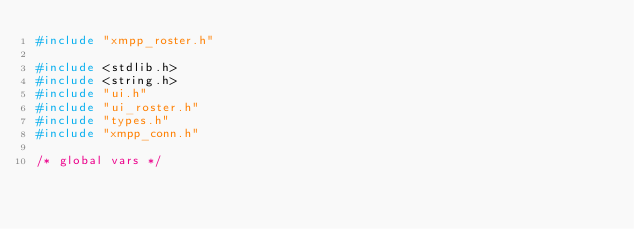Convert code to text. <code><loc_0><loc_0><loc_500><loc_500><_C_>#include "xmpp_roster.h"

#include <stdlib.h>
#include <string.h>
#include "ui.h"
#include "ui_roster.h"
#include "types.h"
#include "xmpp_conn.h"

/* global vars */</code> 